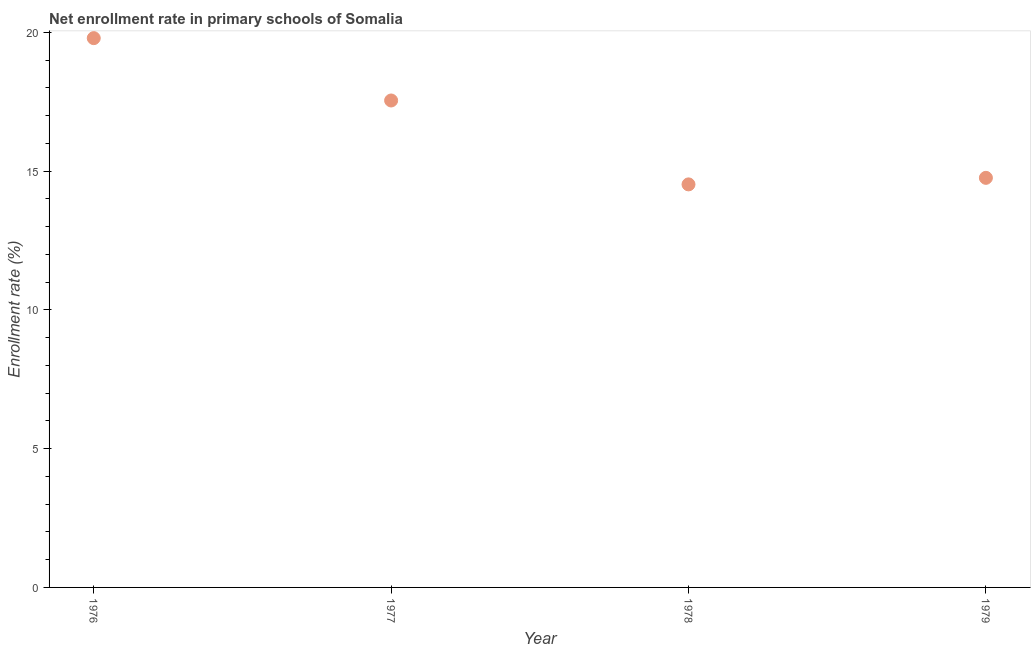What is the net enrollment rate in primary schools in 1978?
Provide a short and direct response. 14.52. Across all years, what is the maximum net enrollment rate in primary schools?
Keep it short and to the point. 19.79. Across all years, what is the minimum net enrollment rate in primary schools?
Make the answer very short. 14.52. In which year was the net enrollment rate in primary schools maximum?
Ensure brevity in your answer.  1976. In which year was the net enrollment rate in primary schools minimum?
Your response must be concise. 1978. What is the sum of the net enrollment rate in primary schools?
Your answer should be compact. 66.62. What is the difference between the net enrollment rate in primary schools in 1976 and 1977?
Give a very brief answer. 2.25. What is the average net enrollment rate in primary schools per year?
Give a very brief answer. 16.66. What is the median net enrollment rate in primary schools?
Your answer should be compact. 16.15. What is the ratio of the net enrollment rate in primary schools in 1976 to that in 1977?
Your response must be concise. 1.13. Is the net enrollment rate in primary schools in 1977 less than that in 1979?
Keep it short and to the point. No. Is the difference between the net enrollment rate in primary schools in 1976 and 1977 greater than the difference between any two years?
Provide a short and direct response. No. What is the difference between the highest and the second highest net enrollment rate in primary schools?
Make the answer very short. 2.25. What is the difference between the highest and the lowest net enrollment rate in primary schools?
Ensure brevity in your answer.  5.27. In how many years, is the net enrollment rate in primary schools greater than the average net enrollment rate in primary schools taken over all years?
Give a very brief answer. 2. Does the net enrollment rate in primary schools monotonically increase over the years?
Offer a terse response. No. How many dotlines are there?
Keep it short and to the point. 1. Does the graph contain any zero values?
Offer a terse response. No. What is the title of the graph?
Offer a very short reply. Net enrollment rate in primary schools of Somalia. What is the label or title of the Y-axis?
Offer a terse response. Enrollment rate (%). What is the Enrollment rate (%) in 1976?
Provide a short and direct response. 19.79. What is the Enrollment rate (%) in 1977?
Keep it short and to the point. 17.55. What is the Enrollment rate (%) in 1978?
Provide a short and direct response. 14.52. What is the Enrollment rate (%) in 1979?
Your answer should be very brief. 14.76. What is the difference between the Enrollment rate (%) in 1976 and 1977?
Give a very brief answer. 2.25. What is the difference between the Enrollment rate (%) in 1976 and 1978?
Ensure brevity in your answer.  5.27. What is the difference between the Enrollment rate (%) in 1976 and 1979?
Your response must be concise. 5.03. What is the difference between the Enrollment rate (%) in 1977 and 1978?
Your answer should be very brief. 3.02. What is the difference between the Enrollment rate (%) in 1977 and 1979?
Your answer should be very brief. 2.79. What is the difference between the Enrollment rate (%) in 1978 and 1979?
Keep it short and to the point. -0.24. What is the ratio of the Enrollment rate (%) in 1976 to that in 1977?
Offer a very short reply. 1.13. What is the ratio of the Enrollment rate (%) in 1976 to that in 1978?
Provide a short and direct response. 1.36. What is the ratio of the Enrollment rate (%) in 1976 to that in 1979?
Offer a terse response. 1.34. What is the ratio of the Enrollment rate (%) in 1977 to that in 1978?
Provide a succinct answer. 1.21. What is the ratio of the Enrollment rate (%) in 1977 to that in 1979?
Offer a terse response. 1.19. 